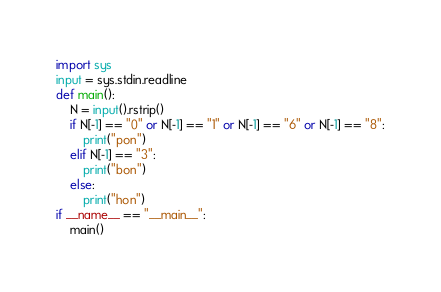Convert code to text. <code><loc_0><loc_0><loc_500><loc_500><_Python_>import sys
input = sys.stdin.readline
def main():
    N = input().rstrip()
    if N[-1] == "0" or N[-1] == "1" or N[-1] == "6" or N[-1] == "8":
        print("pon")
    elif N[-1] == "3":
        print("bon")
    else:
        print("hon")
if __name__ == "__main__":
    main()</code> 